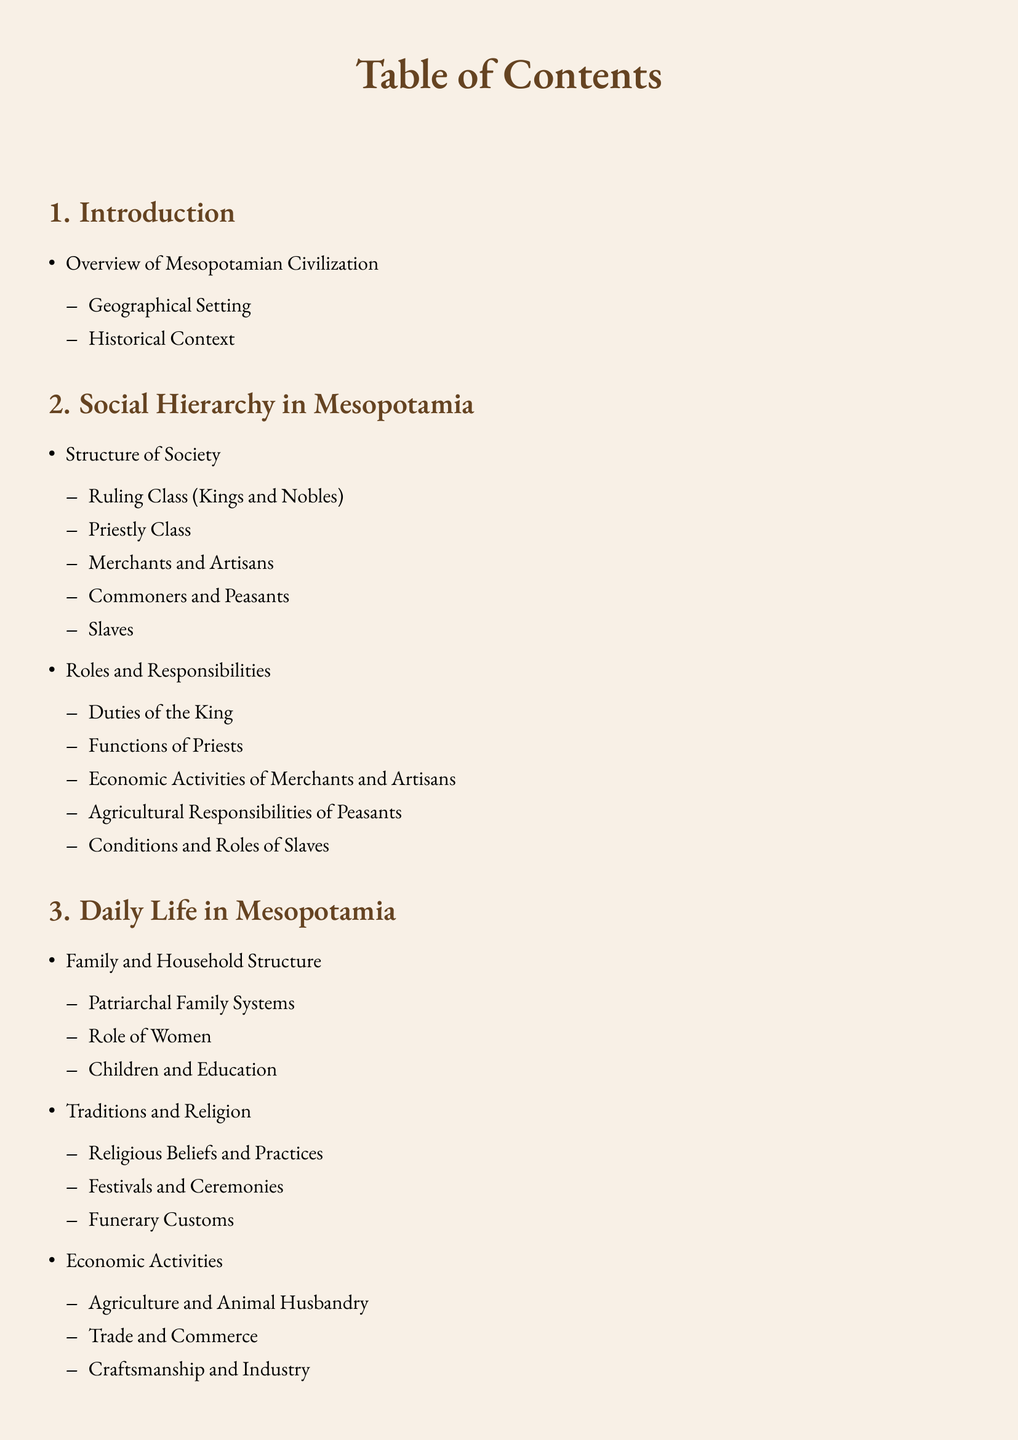What is the first section of the document? The first section of the document is titled "Introduction".
Answer: Introduction How many classes are detailed in the social hierarchy? The social hierarchy details five classes: Ruling Class, Priestly Class, Merchants and Artisans, Commoners and Peasants, and Slaves.
Answer: Five What role is primarily associated with the patriarchal family systems? The role primarily associated with the patriarchal family systems is that of the male head of the household.
Answer: Male head What economic activity is connected to animals? The economic activity connected to animals is Animal Husbandry.
Answer: Animal Husbandry Which group holds religious duties in Mesopotamian society? The group that holds religious duties is the Priestly Class.
Answer: Priestly Class What are the three main themes under Daily Life in Mesopotamia? The three main themes are Family and Household Structure, Traditions and Religion, and Economic Activities.
Answer: Family and Household Structure, Traditions and Religion, Economic Activities What type of customs are included in the traditions of Mesopotamia? The type of customs included are Funerary Customs.
Answer: Funerary Customs What does the document conclude about the Mesopotamian social structures? The document concludes about the Influence and Legacy of Mesopotamian Social Structures.
Answer: Influence and Legacy How many subsections are in the Conclusion? The Conclusion contains one subsection.
Answer: One 